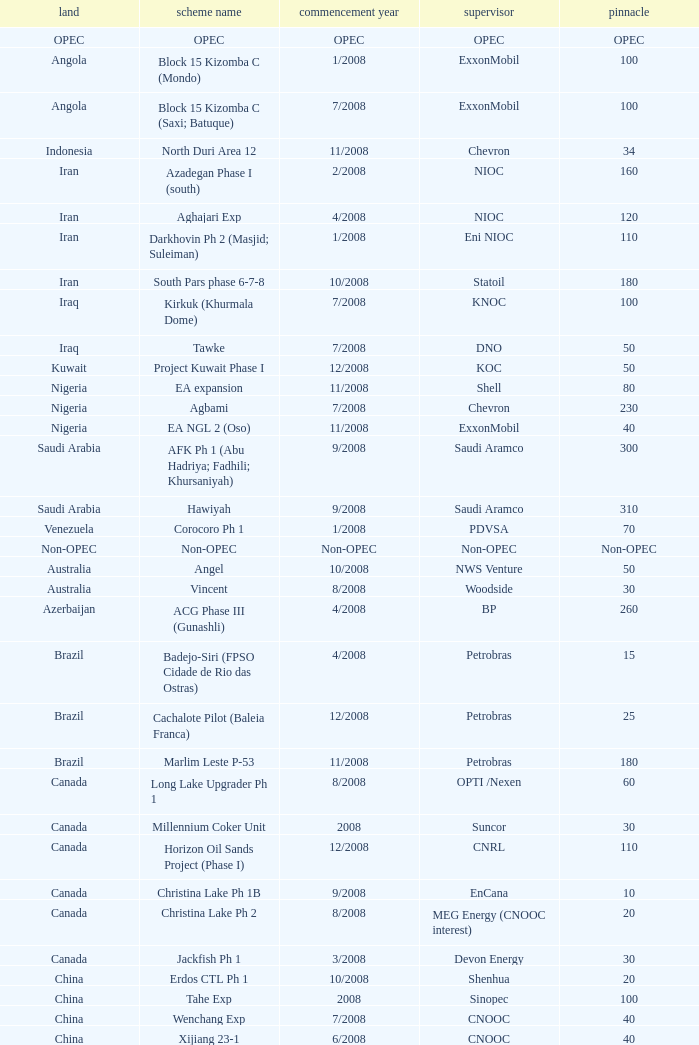What is the Peak with a Project Name that is talakan ph 1? 60.0. 